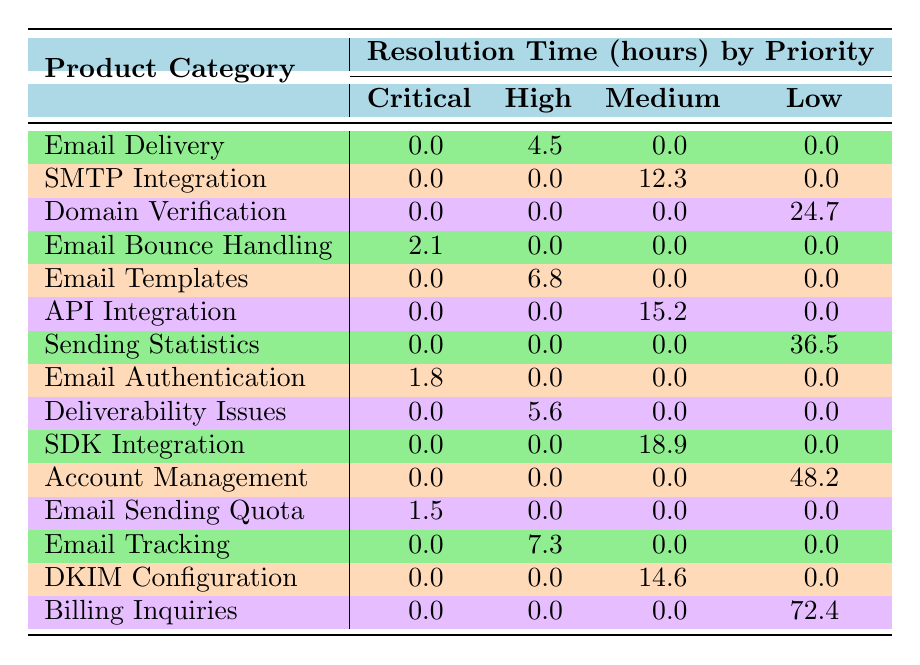What is the resolution time for "Email Delivery" tickets marked as "Critical"? There are no tickets marked as "Critical" under the "Email Delivery" product category in the table. Therefore, the resolution time is 0.0 hours.
Answer: 0.0 Which product category has the longest resolution time for "Low" priority tickets? The "Billing Inquiries" product category has the longest resolution time at 72.4 hours for "Low" priority tickets, as it is the only entry under that priority with a value.
Answer: 72.4 What is the total resolution time for "High" priority tickets across all product categories? The total resolution time for "High" priority tickets is calculated by summing 4.5 (Email Delivery), 6.8 (Email Templates), 5.6 (Deliverability Issues), 7.3 (Email Tracking) = 24.2 hours.
Answer: 24.2 Are there any product categories with no "Medium" priority tickets? Yes, the categories "Email Delivery," "Email Bounce Handling," "Email Templates," "Email Authentication," and "Billing Inquiries" have no "Medium" priority tickets, as they have a value of 0.0 hours listed.
Answer: Yes What is the average resolution time for "Critical" priority tickets? The "Critical" priority tickets have resolution times of 2.1 (Email Bounce Handling), 1.8 (Email Authentication), and 1.5 (Email Sending Quota). To find the average, sum the values: 2.1 + 1.8 + 1.5 = 5.4 hours, and divide by the number of tickets: 5.4 / 3 = 1.8 hours.
Answer: 1.8 